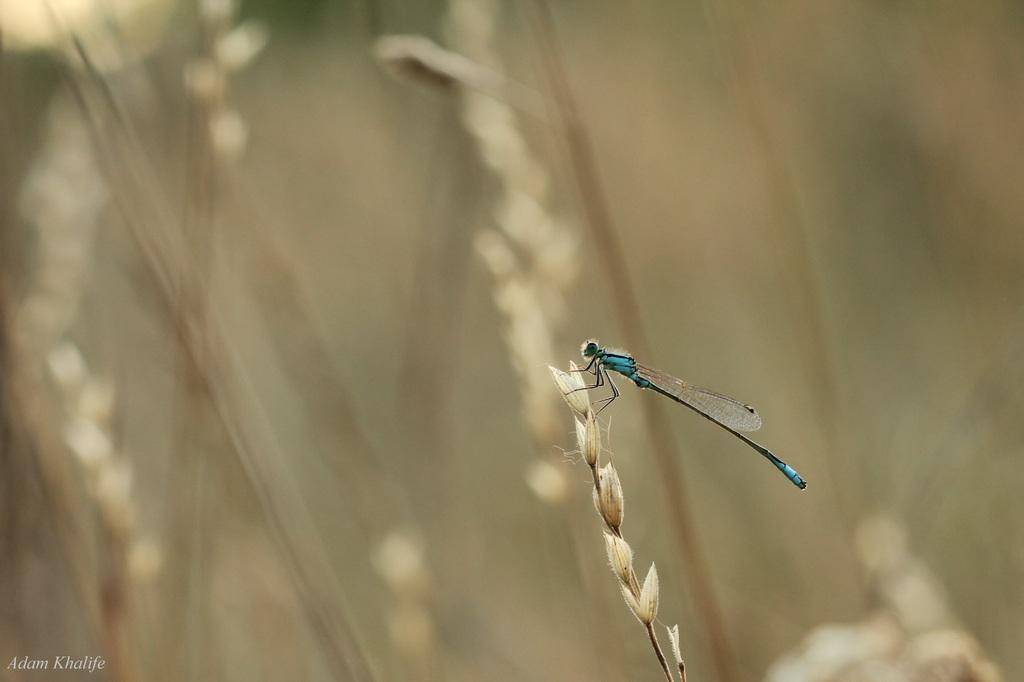What is present in the foreground of the image? There is a fly on a plant in the foreground of the image. How would you describe the background of the image? The background of the image is blurred. What type of treatment is the fly receiving in the image? There is no indication in the image that the fly is receiving any treatment. 